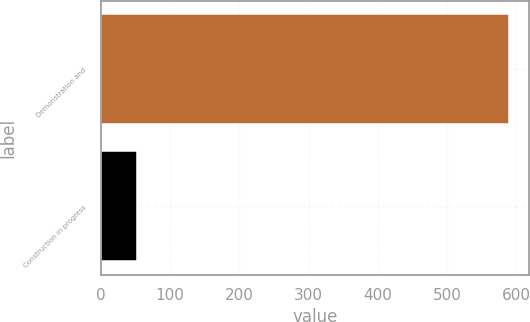<chart> <loc_0><loc_0><loc_500><loc_500><bar_chart><fcel>Demonstration and<fcel>Construction in progress<nl><fcel>589<fcel>52<nl></chart> 